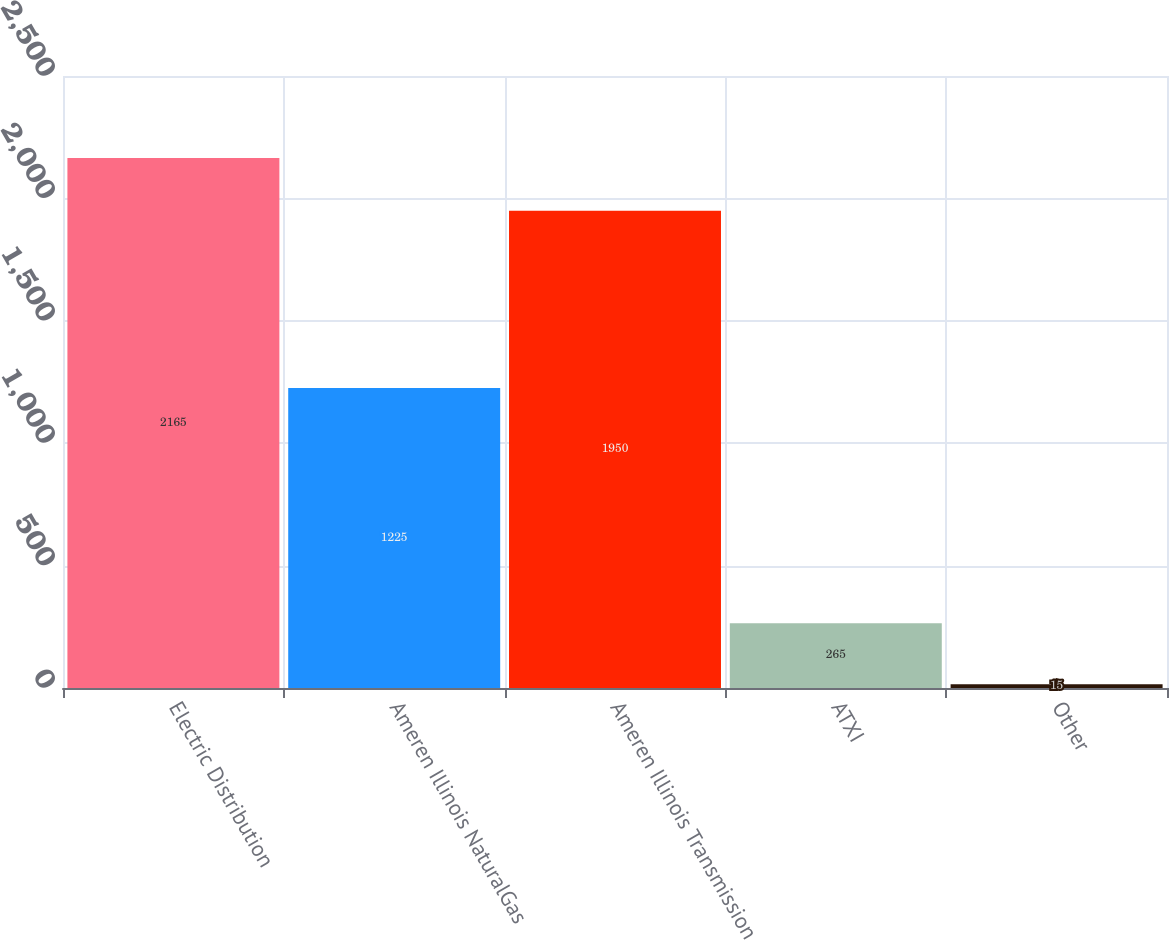Convert chart. <chart><loc_0><loc_0><loc_500><loc_500><bar_chart><fcel>Electric Distribution<fcel>Ameren Illinois NaturalGas<fcel>Ameren Illinois Transmission<fcel>ATXI<fcel>Other<nl><fcel>2165<fcel>1225<fcel>1950<fcel>265<fcel>15<nl></chart> 